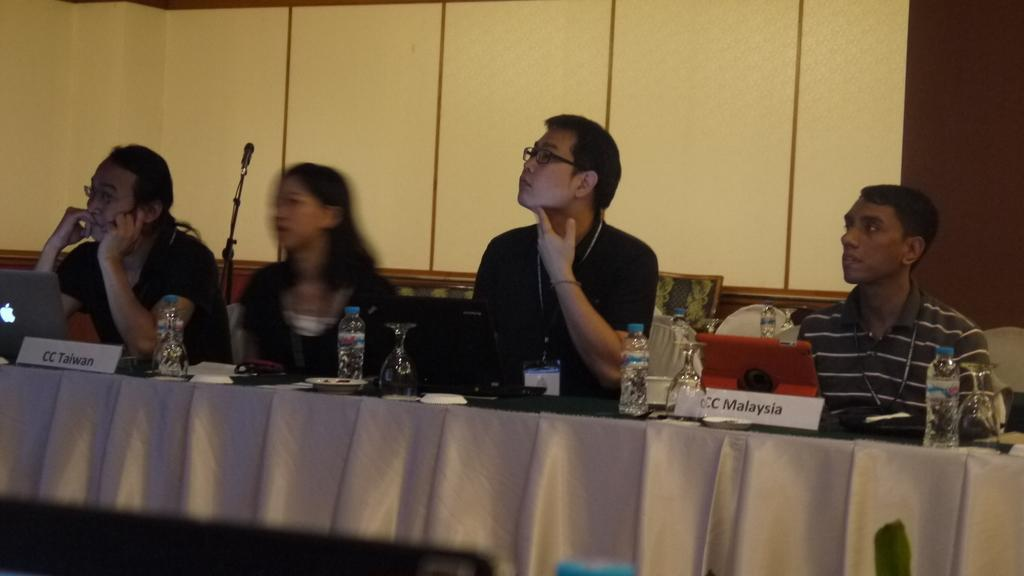What are the people in the image doing? The people in the image are sitting on chairs. Where are the chairs located in relation to the table? The chairs are in front of a table. What objects can be seen on the table? There is a microphone, a laptop, and a water bottle on the table. What type of setting does the image resemble? The setting resembles a meeting room. Can you tell me how many actors are performing on the table in the image? There are no actors performing on the table in the image; it is a meeting room setting with a microphone, laptop, and water bottle on the table. What unit of measurement is used to determine the height of the fall in the image? There is no fall present in the image; it is a meeting room setting with people sitting on chairs, a table, and various objects on the table. 